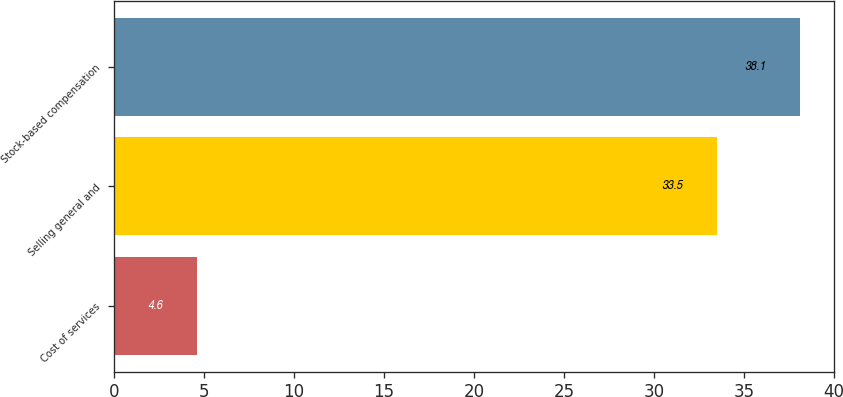Convert chart. <chart><loc_0><loc_0><loc_500><loc_500><bar_chart><fcel>Cost of services<fcel>Selling general and<fcel>Stock-based compensation<nl><fcel>4.6<fcel>33.5<fcel>38.1<nl></chart> 